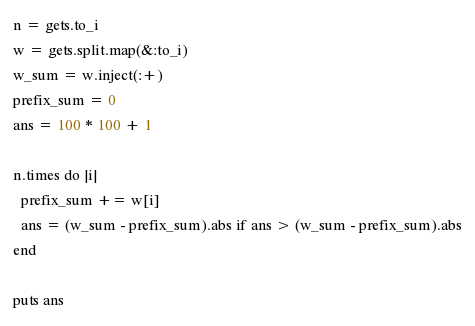<code> <loc_0><loc_0><loc_500><loc_500><_Ruby_>n = gets.to_i
w = gets.split.map(&:to_i)
w_sum = w.inject(:+)
prefix_sum = 0
ans = 100 * 100 + 1

n.times do |i|
  prefix_sum += w[i]
  ans = (w_sum - prefix_sum).abs if ans > (w_sum - prefix_sum).abs
end

puts ans</code> 